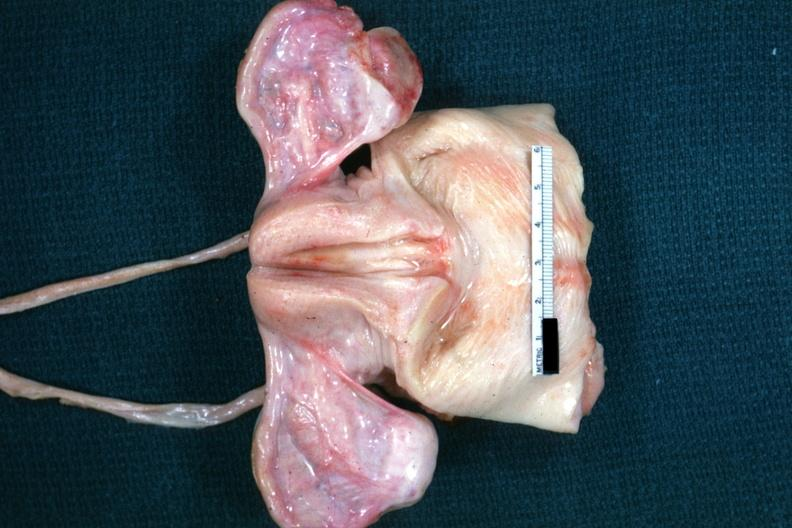where does this belong to?
Answer the question using a single word or phrase. Female reproductive system 